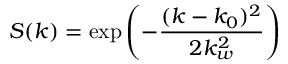<formula> <loc_0><loc_0><loc_500><loc_500>S ( k ) = \exp \left ( - \frac { ( k - k _ { 0 } ) ^ { 2 } } { 2 k _ { w } ^ { 2 } } \right )</formula> 